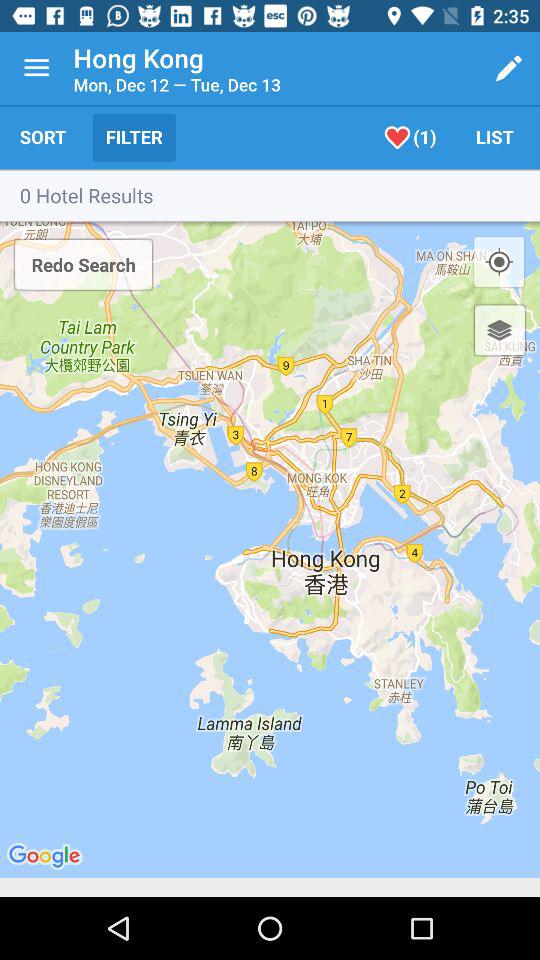What is the day on December 13? The day on December 13 is Tuesday. 